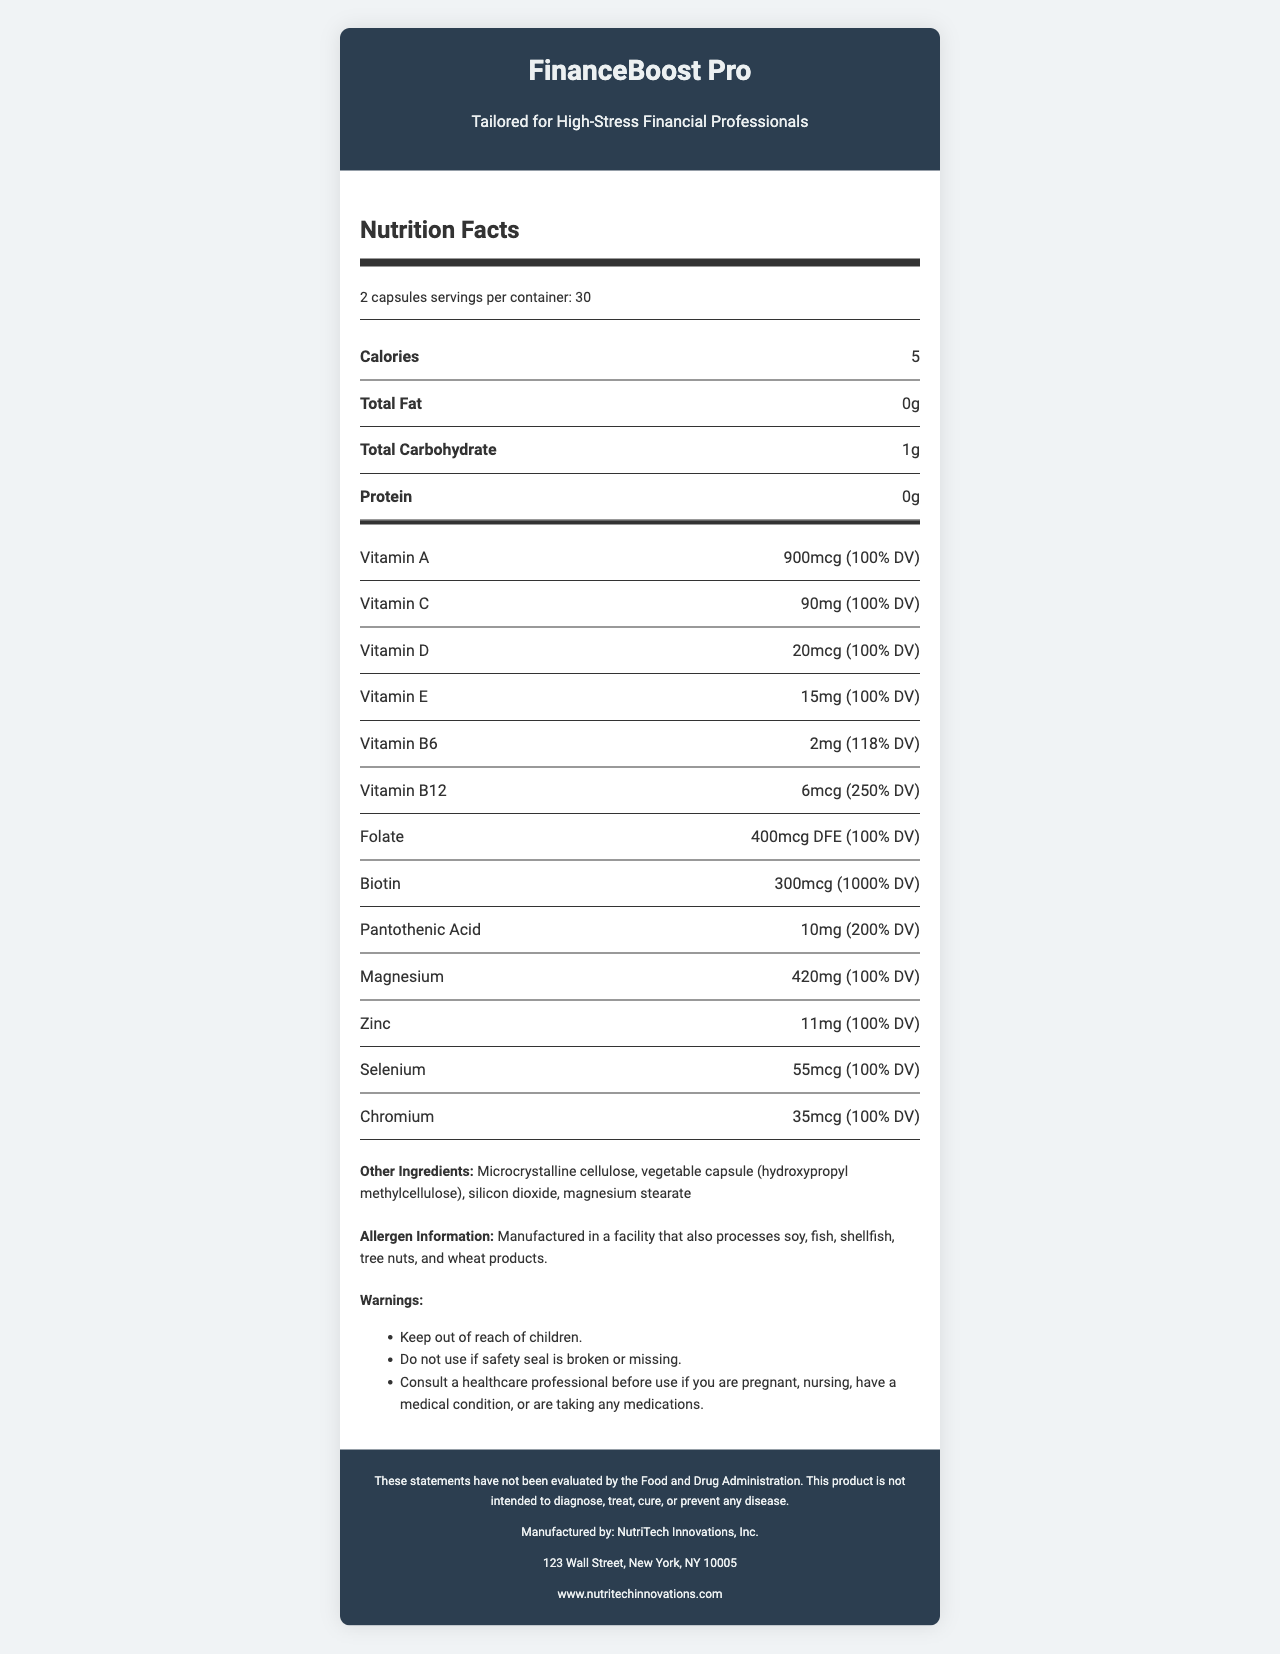what is the serving size of FinanceBoost Pro? The serving size for FinanceBoost Pro is explicitly mentioned in the nutrition facts as "2 capsules".
Answer: 2 capsules how many servings are there per container? The nutrition facts label indicates that there are 30 servings per container.
Answer: 30 how many calories are in a serving? The label states that each serving contains 5 calories.
Answer: 5 what is the amount of Vitamin C in FinanceBoost Pro? The label specifies that each serving contains 90mg of Vitamin C, which is 100% of the daily value.
Answer: 90mg (100% DV) which ingredient in the supplement has the highest daily value percentage? Biotin has the highest daily value percentage at 1000%, as listed on the nutrition label.
Answer: Biotin (300mcg, 1000% DV) what is the manufacturer of the supplement? The document lists NutriTech Innovations, Inc. as the manufacturer of the supplement.
Answer: NutriTech Innovations, Inc. where is the manufacturer located? The manufacturer's address is provided at the end of the document, specifying they are located at 123 Wall Street, New York, NY 10005.
Answer: 123 Wall Street, New York, NY 10005 what are the suggested use instructions for this supplement? The suggested use instructions state to take 2 capsules daily with food or as directed by a healthcare professional.
Answer: Take 2 capsules daily with food or as directed by your healthcare professional. what are some of the non-active ingredients in FinanceBoost Pro? The other ingredients are listed in the document under the "Other Ingredients" section.
Answer: Microcrystalline cellulose, vegetable capsule (hydroxypropyl methylcellulose), silicon dioxide, magnesium stearate what is the website of the manufacturer? The website of the manufacturer is provided at the end of the document.
Answer: www.nutritechinnovations.com what does the disclaimer say? The disclaimer clearly states that the product's claims have not been evaluated by the FDA and are not intended to diagnose, treat, cure, or prevent any disease.
Answer: These statements have not been evaluated by the Food and Drug Administration. This product is not intended to diagnose, treat, cure, or prevent any disease. what should you do if the safety seal is broken or missing? The warnings section advises not to use the product if the safety seal is broken or missing.
Answer: Do not use which of these vitamins has the highest quantity in FinanceBoost Pro? A. Vitamin A B. Vitamin C C. Vitamin B6 D. Biotin Biotin is present in the highest quantity (300mcg) compared to the other listed vitamins.
Answer: D. Biotin what is the correct daily value percentage for magnesium in the supplement? A. 100% B. 118% C. 200% D. 250% The label indicates that the daily value percentage for magnesium is 100%.
Answer: A. 100% is the product safe to take for pregnant women without consultation? The warnings section suggests consulting a healthcare professional before use if pregnant, nursing, have a medical condition, or are taking any medications.
Answer: No please summarize the Nutrition Facts label provided for FinanceBoost Pro. This summary provides a high-level overview of the key nutritional content, serving details, and usage precautions for FinanceBoost Pro as captured in the Nutrition Facts label.
Answer: FinanceBoost Pro is a vitamin supplement designed for high-stress financial professionals. Each serving size is 2 capsules and there are 30 servings per container. The supplement contains 5 calories per serving and provides various vitamins and minerals. Notable contents include 100% DV of vitamins A, C, D, E, 250% DV of Vitamin B12, and 1000% DV of Biotin among others. It also contains ingredients aimed at stress support, like L-Theanine, Rhodiola Rosea Extract, and Ashwagandha Extract. The product should be stored in a cool, dry place, and precautions are advised for pregnant or nursing individuals and those with medical conditions or on medications. what is the exact amount of Vitamin K in FinanceBoost Pro? The document does not list Vitamin K; hence, its amount cannot be determined from the provided information.
Answer: Not enough information 